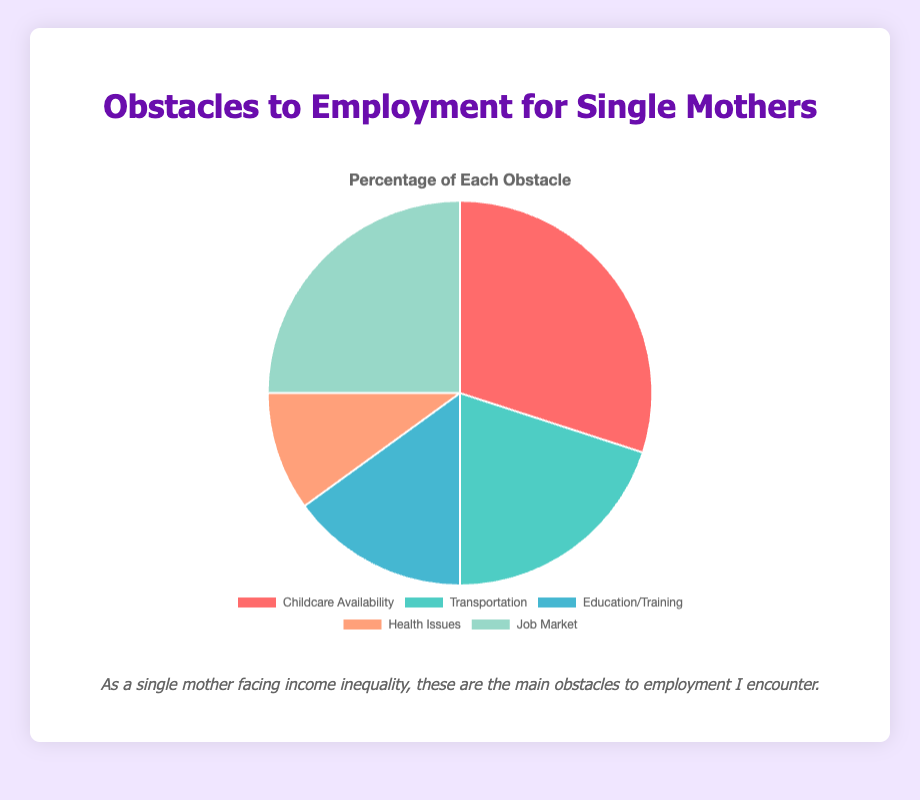Which obstacle is the most significant for employment according to the chart? The chart shows percentages for various obstacles: Childcare Availability (30%), Transportation (20%), Education/Training (15%), Health Issues (10%), Job Market (25%). The highest percentage is for Childcare Availability, indicating it is the most significant obstacle.
Answer: Childcare Availability Which obstacle has the second highest percentage in the chart? The chart lists the obstacles with their percentages: Childcare Availability (30%), Transportation (20%), Education/Training (15%), Health Issues (10%), Job Market (25%). The second highest percentage is for Job Market (25%).
Answer: Job Market What is the combined percentage of Childcare Availability and Health Issues? Childcare Availability is 30%, and Health Issues is 10%. Adding these two percentages together gives 30% + 10% = 40%.
Answer: 40% What percentage of the total obstacles is related to Education/Training and Transportation? Education/Training accounts for 15% and Transportation accounts for 20%. Summing these percentages gives 15% + 20% = 35%.
Answer: 35% Is the percentage of Transportation more than Health Issues by 5% or 10%? The percentage of Transportation is 20%, and Health Issues is 10%. The difference is calculated as 20% - 10% = 10%, so it is more by 10%.
Answer: 10% How does the percentage of Job Market compare to Education/Training? Job Market has a percentage of 25%, and Education/Training has a percentage of 15%. Comparing these, Job Market is greater than Education/Training by 25% - 15% = 10%.
Answer: 10% higher Which categories combined have a percentage equal to that of Childcare Availability alone? Childcare Availability is 30%. Health Issues (10%) + Education/Training (15%) + Transportation (5%) equal 30%. Therefore, these categories combined equal the percentage of Childcare Availability alone.
Answer: Health Issues, Education/Training, and Transportation What percentage of obstacles is related to either Job Market or Transportation? The percentages for Job Market and Transportation are 25% and 20%, respectively. Adding these gives us 25% + 20% = 45%.
Answer: 45% What is the difference in percentage between the most significant obstacle and the least significant obstacle? The most significant obstacle is Childcare Availability at 30%, and the least significant obstacle is Health Issues at 10%. The difference is 30% - 10% = 20%.
Answer: 20% Which category has the smallest percentage and how much is it? The smallest percentage is for Health Issues at 10%, as seen from the chart.
Answer: Health Issues, 10% 